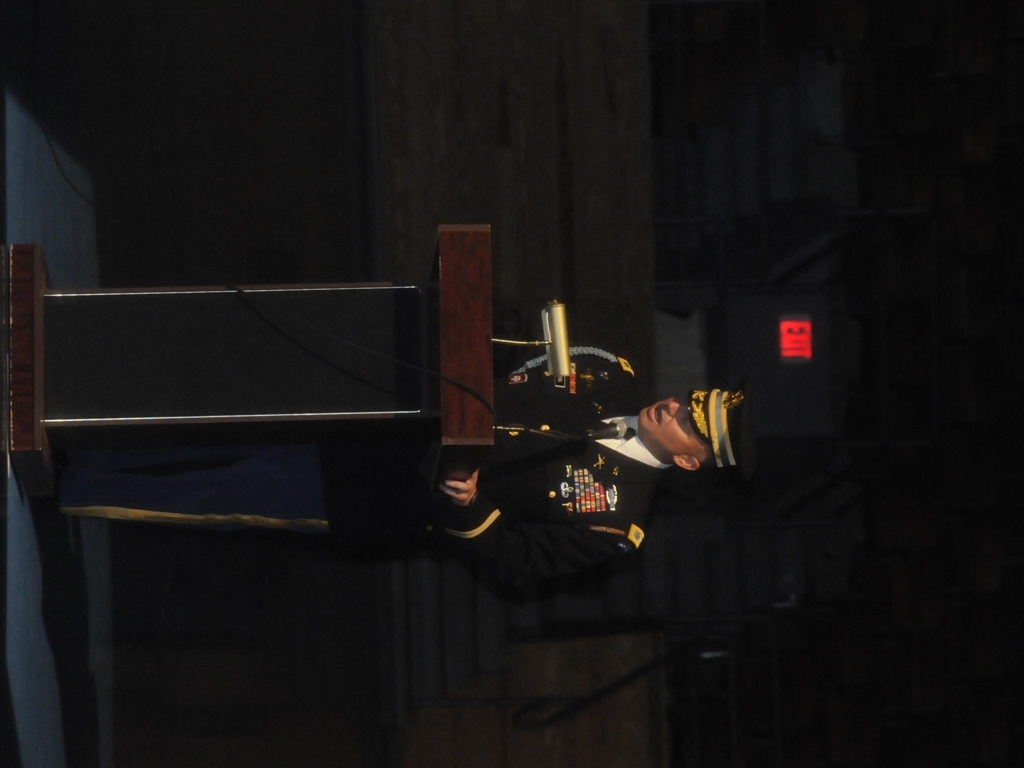How are the details of the speaker in the photo? The details of the speaker in the photo are reasonably clear, though the overall lighting appears dim, and some features are less distinguishable due to shadows. 